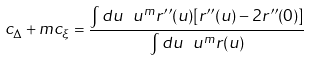Convert formula to latex. <formula><loc_0><loc_0><loc_500><loc_500>c _ { \Delta } + m c _ { \xi } = \frac { \int d u \ u ^ { m } r ^ { \prime \prime } ( u ) [ r ^ { \prime \prime } ( u ) - 2 r ^ { \prime \prime } ( 0 ) ] } { \int d u \ u ^ { m } r ( u ) }</formula> 